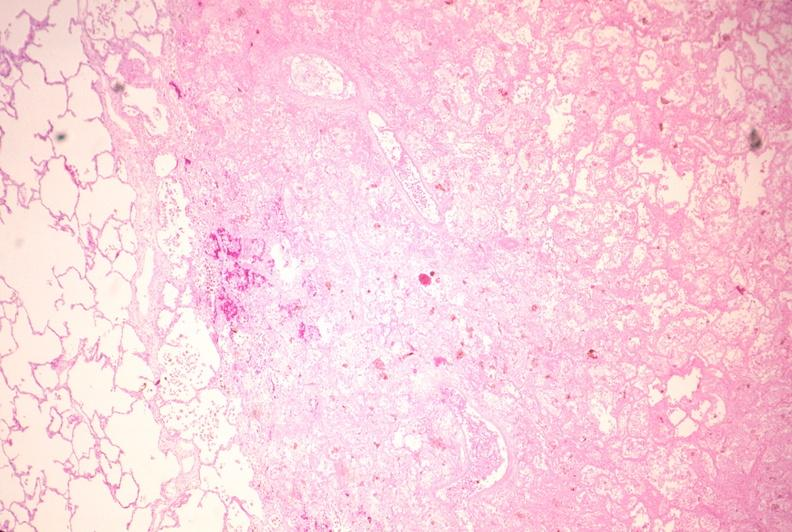what does this image show?
Answer the question using a single word or phrase. Lung 